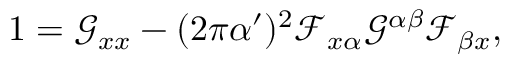<formula> <loc_0><loc_0><loc_500><loc_500>1 = \mathcal { G } _ { x x } - ( 2 \pi \alpha ^ { \prime } ) ^ { 2 } \mathcal { F } _ { x \alpha } \mathcal { G } ^ { \alpha \beta } \mathcal { F } _ { \beta x } ,</formula> 